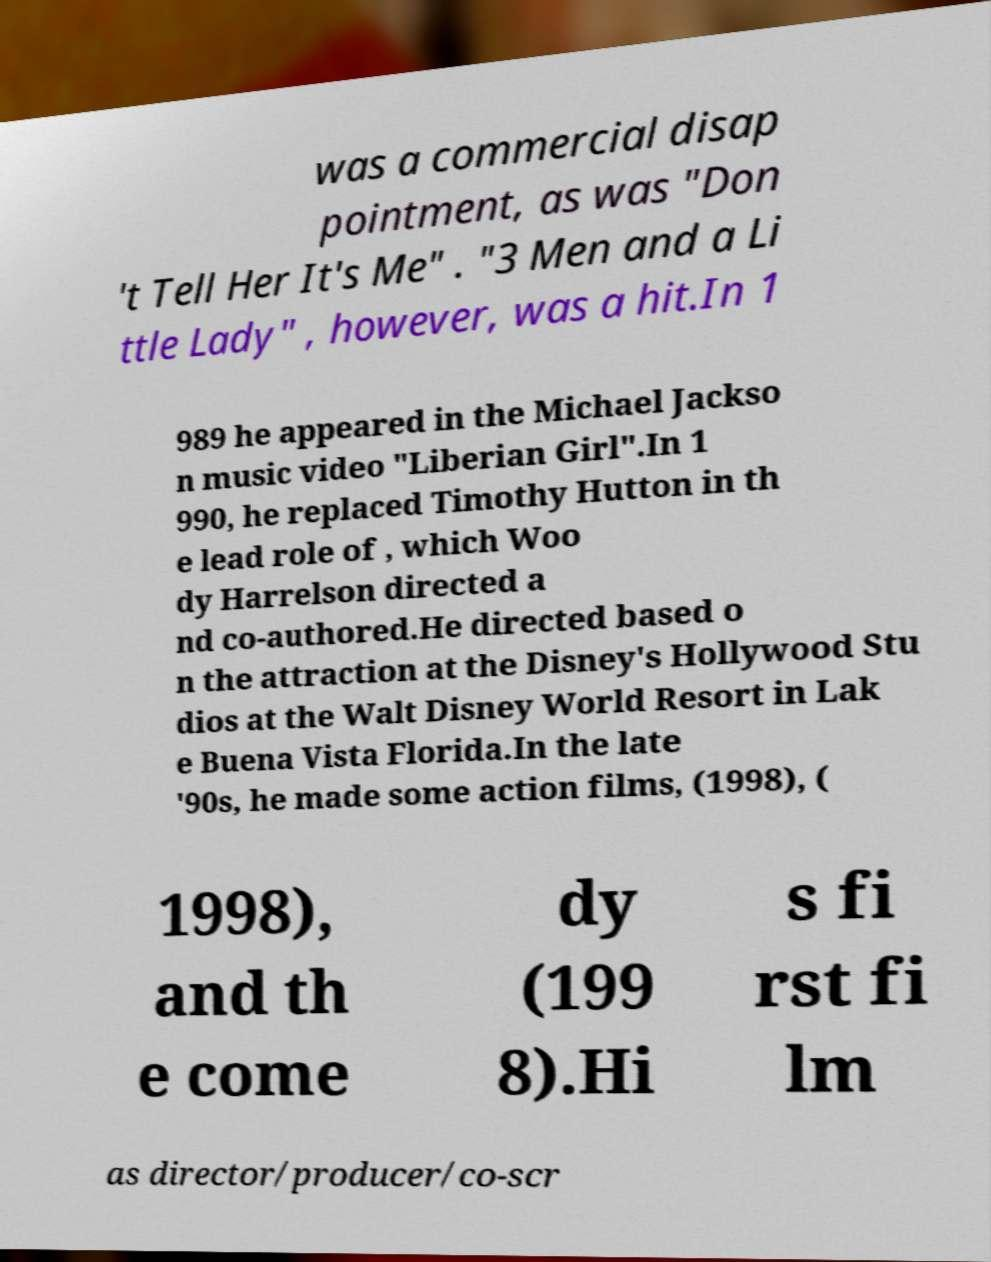Can you accurately transcribe the text from the provided image for me? was a commercial disap pointment, as was "Don 't Tell Her It's Me" . "3 Men and a Li ttle Lady" , however, was a hit.In 1 989 he appeared in the Michael Jackso n music video "Liberian Girl".In 1 990, he replaced Timothy Hutton in th e lead role of , which Woo dy Harrelson directed a nd co-authored.He directed based o n the attraction at the Disney's Hollywood Stu dios at the Walt Disney World Resort in Lak e Buena Vista Florida.In the late '90s, he made some action films, (1998), ( 1998), and th e come dy (199 8).Hi s fi rst fi lm as director/producer/co-scr 